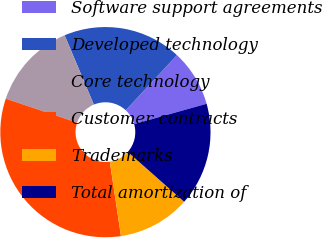Convert chart to OTSL. <chart><loc_0><loc_0><loc_500><loc_500><pie_chart><fcel>Software support agreements<fcel>Developed technology<fcel>Core technology<fcel>Customer contracts<fcel>Trademarks<fcel>Total amortization of<nl><fcel>8.74%<fcel>18.25%<fcel>13.5%<fcel>32.52%<fcel>11.12%<fcel>15.87%<nl></chart> 